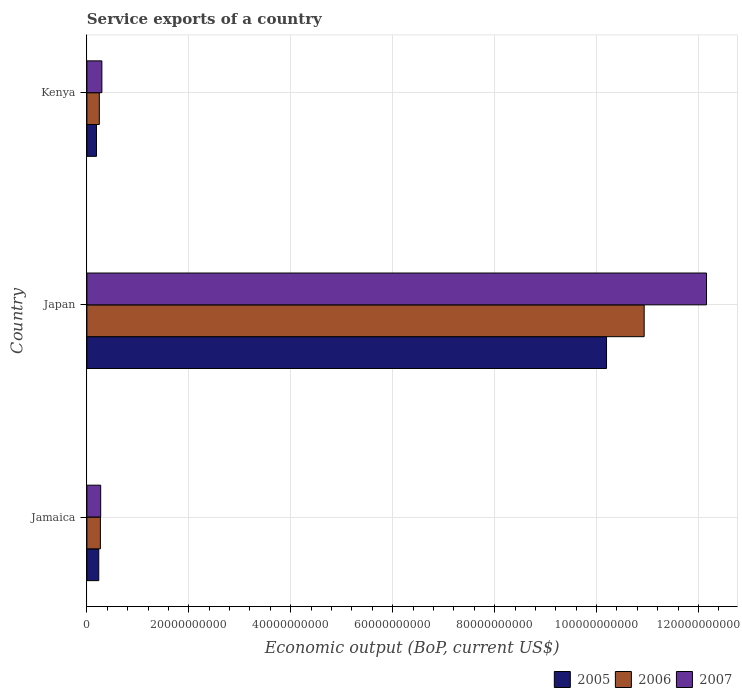Are the number of bars per tick equal to the number of legend labels?
Keep it short and to the point. Yes. How many bars are there on the 1st tick from the top?
Provide a short and direct response. 3. How many bars are there on the 3rd tick from the bottom?
Make the answer very short. 3. What is the label of the 2nd group of bars from the top?
Offer a very short reply. Japan. In how many cases, is the number of bars for a given country not equal to the number of legend labels?
Provide a short and direct response. 0. What is the service exports in 2006 in Japan?
Make the answer very short. 1.09e+11. Across all countries, what is the maximum service exports in 2006?
Your answer should be compact. 1.09e+11. Across all countries, what is the minimum service exports in 2005?
Offer a very short reply. 1.88e+09. In which country was the service exports in 2006 maximum?
Your answer should be compact. Japan. In which country was the service exports in 2006 minimum?
Your answer should be very brief. Kenya. What is the total service exports in 2005 in the graph?
Make the answer very short. 1.06e+11. What is the difference between the service exports in 2007 in Japan and that in Kenya?
Ensure brevity in your answer.  1.19e+11. What is the difference between the service exports in 2006 in Kenya and the service exports in 2007 in Jamaica?
Your answer should be compact. -2.70e+08. What is the average service exports in 2007 per country?
Provide a succinct answer. 4.24e+1. What is the difference between the service exports in 2005 and service exports in 2006 in Japan?
Give a very brief answer. -7.38e+09. In how many countries, is the service exports in 2005 greater than 120000000000 US$?
Your answer should be very brief. 0. What is the ratio of the service exports in 2006 in Jamaica to that in Japan?
Give a very brief answer. 0.02. What is the difference between the highest and the second highest service exports in 2007?
Provide a succinct answer. 1.19e+11. What is the difference between the highest and the lowest service exports in 2006?
Offer a terse response. 1.07e+11. In how many countries, is the service exports in 2005 greater than the average service exports in 2005 taken over all countries?
Your answer should be very brief. 1. What does the 2nd bar from the bottom in Kenya represents?
Give a very brief answer. 2006. Are all the bars in the graph horizontal?
Offer a very short reply. Yes. How many countries are there in the graph?
Give a very brief answer. 3. What is the difference between two consecutive major ticks on the X-axis?
Make the answer very short. 2.00e+1. Are the values on the major ticks of X-axis written in scientific E-notation?
Offer a very short reply. No. Does the graph contain grids?
Your answer should be very brief. Yes. Where does the legend appear in the graph?
Your answer should be compact. Bottom right. How are the legend labels stacked?
Your answer should be very brief. Horizontal. What is the title of the graph?
Provide a succinct answer. Service exports of a country. Does "1982" appear as one of the legend labels in the graph?
Provide a succinct answer. No. What is the label or title of the X-axis?
Provide a succinct answer. Economic output (BoP, current US$). What is the Economic output (BoP, current US$) of 2005 in Jamaica?
Offer a terse response. 2.33e+09. What is the Economic output (BoP, current US$) of 2006 in Jamaica?
Offer a very short reply. 2.65e+09. What is the Economic output (BoP, current US$) in 2007 in Jamaica?
Provide a short and direct response. 2.71e+09. What is the Economic output (BoP, current US$) of 2005 in Japan?
Your answer should be very brief. 1.02e+11. What is the Economic output (BoP, current US$) of 2006 in Japan?
Ensure brevity in your answer.  1.09e+11. What is the Economic output (BoP, current US$) in 2007 in Japan?
Offer a very short reply. 1.22e+11. What is the Economic output (BoP, current US$) of 2005 in Kenya?
Your answer should be very brief. 1.88e+09. What is the Economic output (BoP, current US$) in 2006 in Kenya?
Keep it short and to the point. 2.44e+09. What is the Economic output (BoP, current US$) of 2007 in Kenya?
Offer a terse response. 2.94e+09. Across all countries, what is the maximum Economic output (BoP, current US$) of 2005?
Offer a terse response. 1.02e+11. Across all countries, what is the maximum Economic output (BoP, current US$) of 2006?
Give a very brief answer. 1.09e+11. Across all countries, what is the maximum Economic output (BoP, current US$) in 2007?
Your answer should be very brief. 1.22e+11. Across all countries, what is the minimum Economic output (BoP, current US$) of 2005?
Your response must be concise. 1.88e+09. Across all countries, what is the minimum Economic output (BoP, current US$) in 2006?
Provide a short and direct response. 2.44e+09. Across all countries, what is the minimum Economic output (BoP, current US$) in 2007?
Provide a short and direct response. 2.71e+09. What is the total Economic output (BoP, current US$) of 2005 in the graph?
Your answer should be compact. 1.06e+11. What is the total Economic output (BoP, current US$) in 2006 in the graph?
Provide a short and direct response. 1.14e+11. What is the total Economic output (BoP, current US$) in 2007 in the graph?
Your response must be concise. 1.27e+11. What is the difference between the Economic output (BoP, current US$) in 2005 in Jamaica and that in Japan?
Keep it short and to the point. -9.96e+1. What is the difference between the Economic output (BoP, current US$) in 2006 in Jamaica and that in Japan?
Keep it short and to the point. -1.07e+11. What is the difference between the Economic output (BoP, current US$) in 2007 in Jamaica and that in Japan?
Offer a terse response. -1.19e+11. What is the difference between the Economic output (BoP, current US$) in 2005 in Jamaica and that in Kenya?
Ensure brevity in your answer.  4.47e+08. What is the difference between the Economic output (BoP, current US$) of 2006 in Jamaica and that in Kenya?
Your answer should be very brief. 2.12e+08. What is the difference between the Economic output (BoP, current US$) of 2007 in Jamaica and that in Kenya?
Give a very brief answer. -2.33e+08. What is the difference between the Economic output (BoP, current US$) in 2005 in Japan and that in Kenya?
Your answer should be very brief. 1.00e+11. What is the difference between the Economic output (BoP, current US$) in 2006 in Japan and that in Kenya?
Ensure brevity in your answer.  1.07e+11. What is the difference between the Economic output (BoP, current US$) of 2007 in Japan and that in Kenya?
Offer a very short reply. 1.19e+11. What is the difference between the Economic output (BoP, current US$) of 2005 in Jamaica and the Economic output (BoP, current US$) of 2006 in Japan?
Your answer should be compact. -1.07e+11. What is the difference between the Economic output (BoP, current US$) of 2005 in Jamaica and the Economic output (BoP, current US$) of 2007 in Japan?
Ensure brevity in your answer.  -1.19e+11. What is the difference between the Economic output (BoP, current US$) of 2006 in Jamaica and the Economic output (BoP, current US$) of 2007 in Japan?
Your answer should be compact. -1.19e+11. What is the difference between the Economic output (BoP, current US$) of 2005 in Jamaica and the Economic output (BoP, current US$) of 2006 in Kenya?
Provide a short and direct response. -1.07e+08. What is the difference between the Economic output (BoP, current US$) of 2005 in Jamaica and the Economic output (BoP, current US$) of 2007 in Kenya?
Your response must be concise. -6.10e+08. What is the difference between the Economic output (BoP, current US$) of 2006 in Jamaica and the Economic output (BoP, current US$) of 2007 in Kenya?
Offer a very short reply. -2.91e+08. What is the difference between the Economic output (BoP, current US$) in 2005 in Japan and the Economic output (BoP, current US$) in 2006 in Kenya?
Make the answer very short. 9.95e+1. What is the difference between the Economic output (BoP, current US$) in 2005 in Japan and the Economic output (BoP, current US$) in 2007 in Kenya?
Make the answer very short. 9.90e+1. What is the difference between the Economic output (BoP, current US$) of 2006 in Japan and the Economic output (BoP, current US$) of 2007 in Kenya?
Keep it short and to the point. 1.06e+11. What is the average Economic output (BoP, current US$) in 2005 per country?
Make the answer very short. 3.54e+1. What is the average Economic output (BoP, current US$) of 2006 per country?
Provide a succinct answer. 3.81e+1. What is the average Economic output (BoP, current US$) in 2007 per country?
Make the answer very short. 4.24e+1. What is the difference between the Economic output (BoP, current US$) of 2005 and Economic output (BoP, current US$) of 2006 in Jamaica?
Provide a succinct answer. -3.19e+08. What is the difference between the Economic output (BoP, current US$) of 2005 and Economic output (BoP, current US$) of 2007 in Jamaica?
Provide a short and direct response. -3.77e+08. What is the difference between the Economic output (BoP, current US$) in 2006 and Economic output (BoP, current US$) in 2007 in Jamaica?
Ensure brevity in your answer.  -5.79e+07. What is the difference between the Economic output (BoP, current US$) in 2005 and Economic output (BoP, current US$) in 2006 in Japan?
Your response must be concise. -7.38e+09. What is the difference between the Economic output (BoP, current US$) in 2005 and Economic output (BoP, current US$) in 2007 in Japan?
Make the answer very short. -1.96e+1. What is the difference between the Economic output (BoP, current US$) in 2006 and Economic output (BoP, current US$) in 2007 in Japan?
Your response must be concise. -1.22e+1. What is the difference between the Economic output (BoP, current US$) of 2005 and Economic output (BoP, current US$) of 2006 in Kenya?
Your answer should be very brief. -5.54e+08. What is the difference between the Economic output (BoP, current US$) in 2005 and Economic output (BoP, current US$) in 2007 in Kenya?
Offer a very short reply. -1.06e+09. What is the difference between the Economic output (BoP, current US$) in 2006 and Economic output (BoP, current US$) in 2007 in Kenya?
Provide a short and direct response. -5.03e+08. What is the ratio of the Economic output (BoP, current US$) in 2005 in Jamaica to that in Japan?
Provide a short and direct response. 0.02. What is the ratio of the Economic output (BoP, current US$) in 2006 in Jamaica to that in Japan?
Provide a short and direct response. 0.02. What is the ratio of the Economic output (BoP, current US$) in 2007 in Jamaica to that in Japan?
Keep it short and to the point. 0.02. What is the ratio of the Economic output (BoP, current US$) in 2005 in Jamaica to that in Kenya?
Provide a succinct answer. 1.24. What is the ratio of the Economic output (BoP, current US$) in 2006 in Jamaica to that in Kenya?
Give a very brief answer. 1.09. What is the ratio of the Economic output (BoP, current US$) of 2007 in Jamaica to that in Kenya?
Make the answer very short. 0.92. What is the ratio of the Economic output (BoP, current US$) in 2005 in Japan to that in Kenya?
Keep it short and to the point. 54.15. What is the ratio of the Economic output (BoP, current US$) in 2006 in Japan to that in Kenya?
Make the answer very short. 44.87. What is the ratio of the Economic output (BoP, current US$) of 2007 in Japan to that in Kenya?
Offer a terse response. 41.36. What is the difference between the highest and the second highest Economic output (BoP, current US$) in 2005?
Give a very brief answer. 9.96e+1. What is the difference between the highest and the second highest Economic output (BoP, current US$) of 2006?
Provide a succinct answer. 1.07e+11. What is the difference between the highest and the second highest Economic output (BoP, current US$) of 2007?
Your response must be concise. 1.19e+11. What is the difference between the highest and the lowest Economic output (BoP, current US$) of 2005?
Offer a very short reply. 1.00e+11. What is the difference between the highest and the lowest Economic output (BoP, current US$) in 2006?
Your answer should be compact. 1.07e+11. What is the difference between the highest and the lowest Economic output (BoP, current US$) of 2007?
Keep it short and to the point. 1.19e+11. 